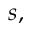<formula> <loc_0><loc_0><loc_500><loc_500>s ,</formula> 